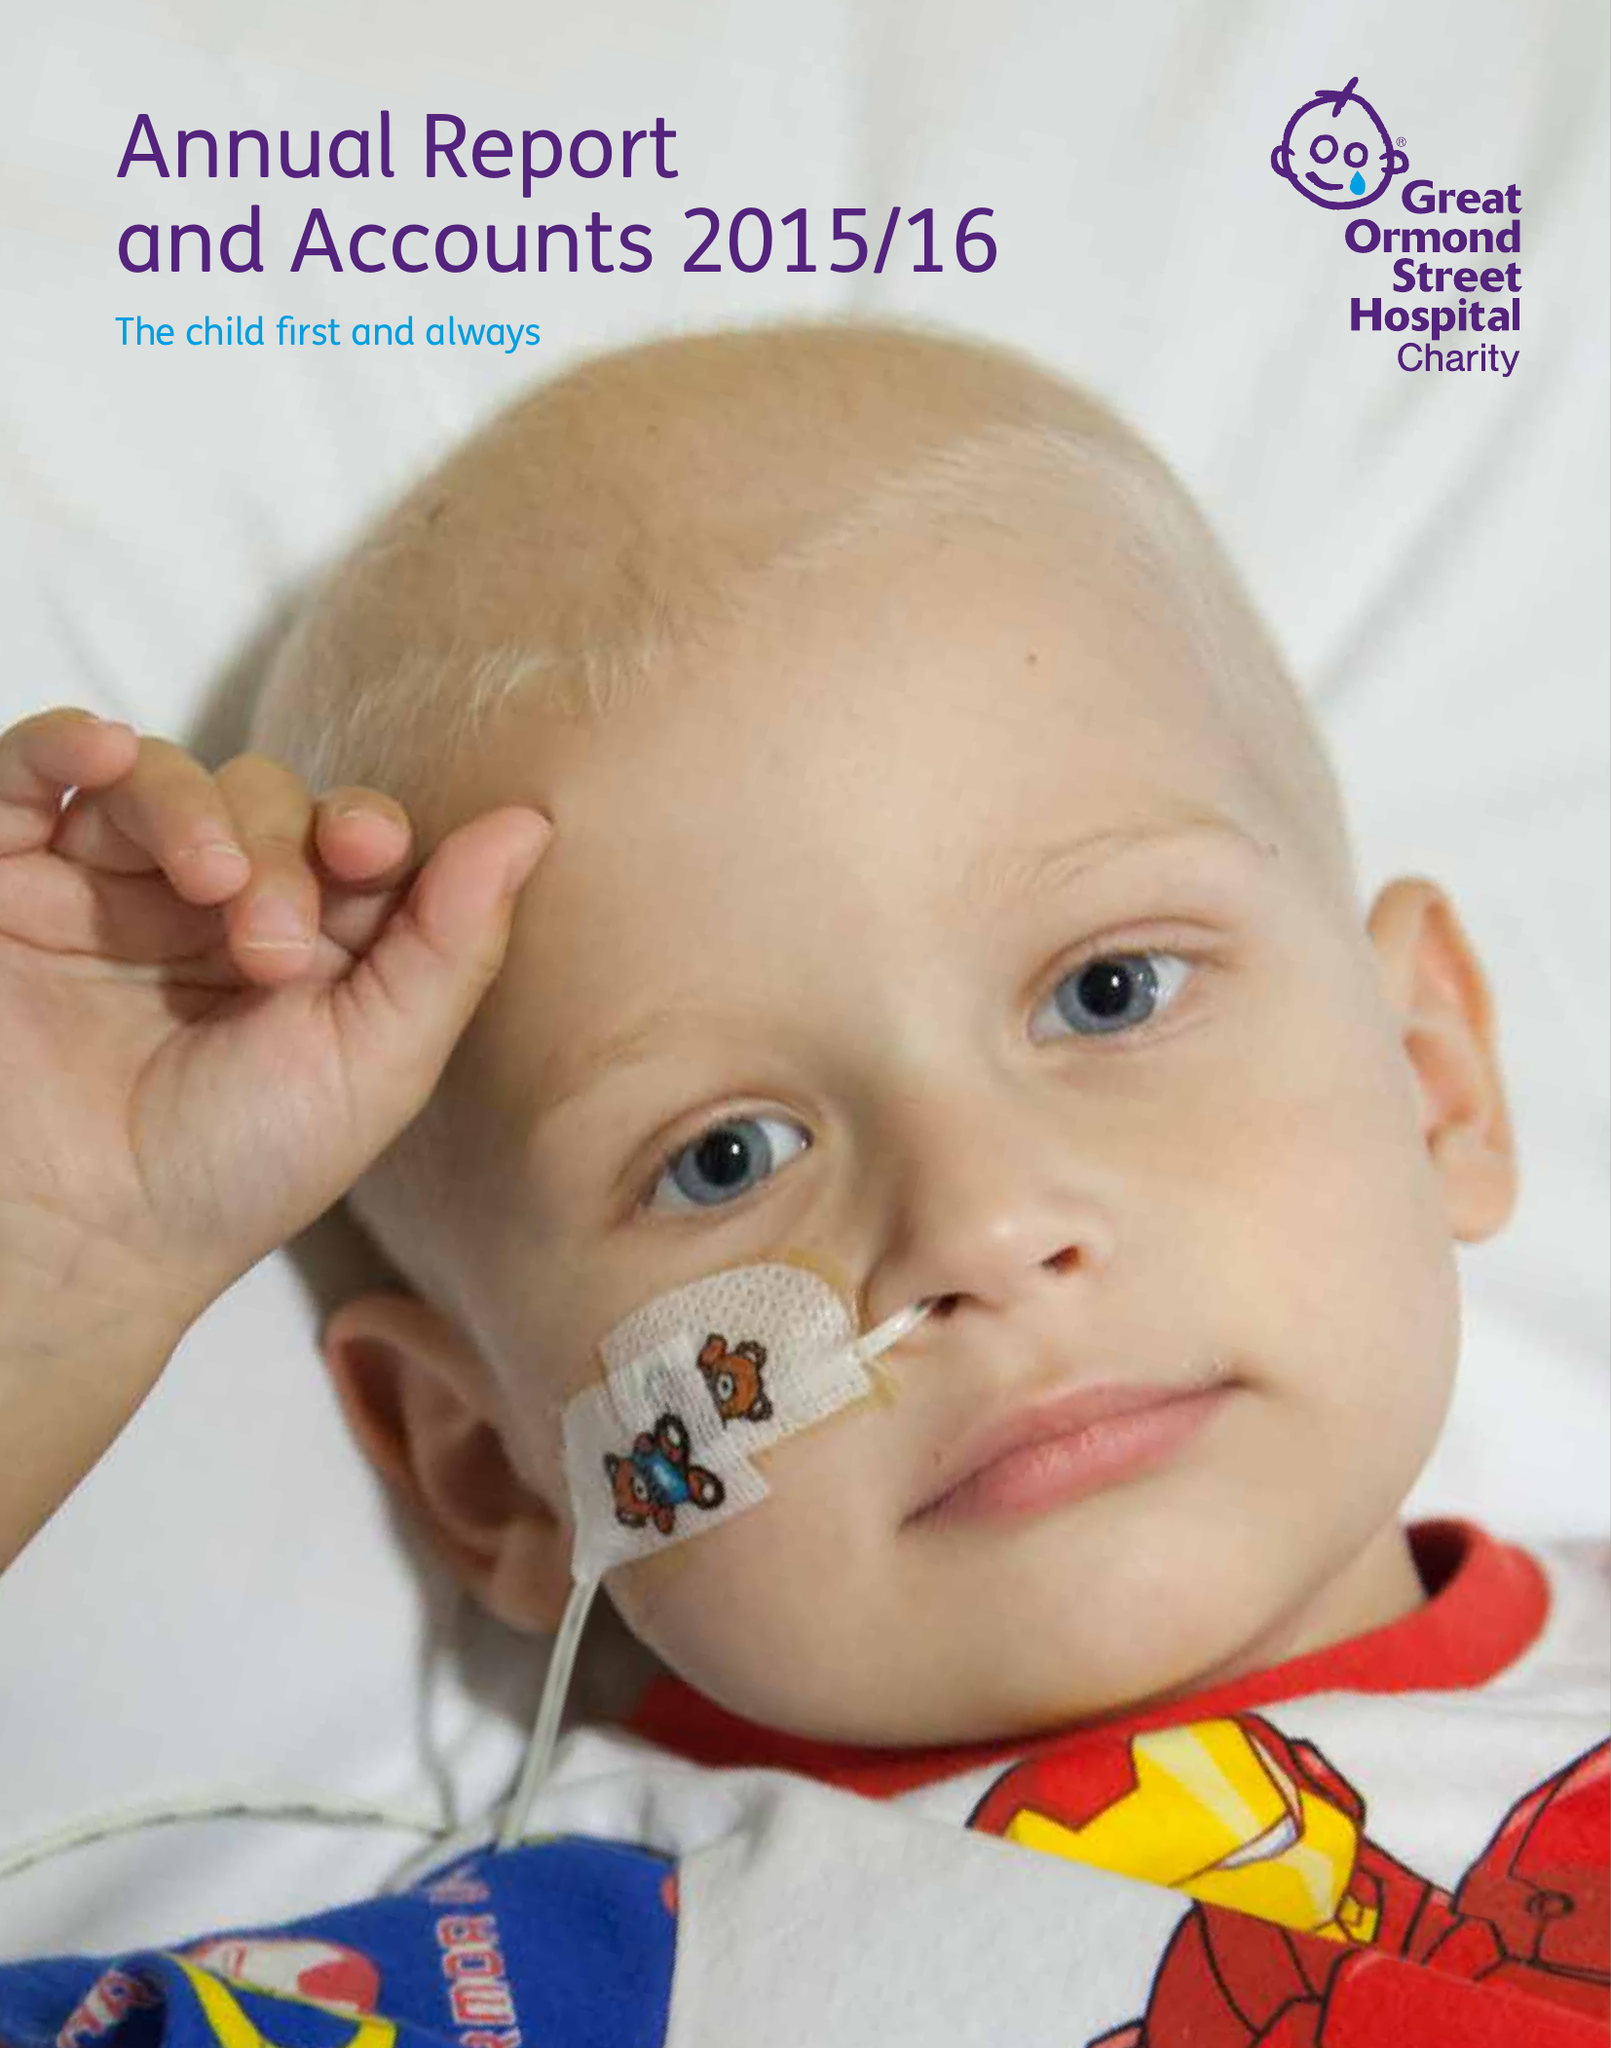What is the value for the spending_annually_in_british_pounds?
Answer the question using a single word or phrase. 51383000.00 